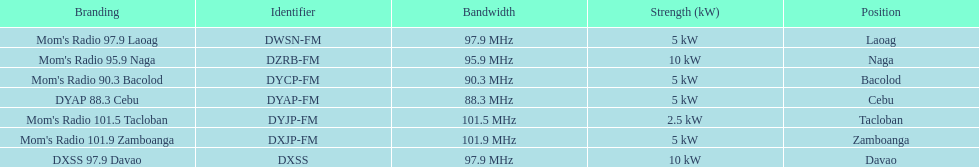What is the radio with the most mhz? Mom's Radio 101.9 Zamboanga. 